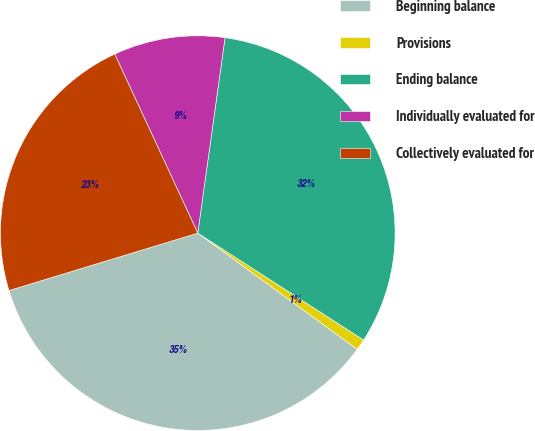Convert chart to OTSL. <chart><loc_0><loc_0><loc_500><loc_500><pie_chart><fcel>Beginning balance<fcel>Provisions<fcel>Ending balance<fcel>Individually evaluated for<fcel>Collectively evaluated for<nl><fcel>35.28%<fcel>0.91%<fcel>31.91%<fcel>9.12%<fcel>22.79%<nl></chart> 